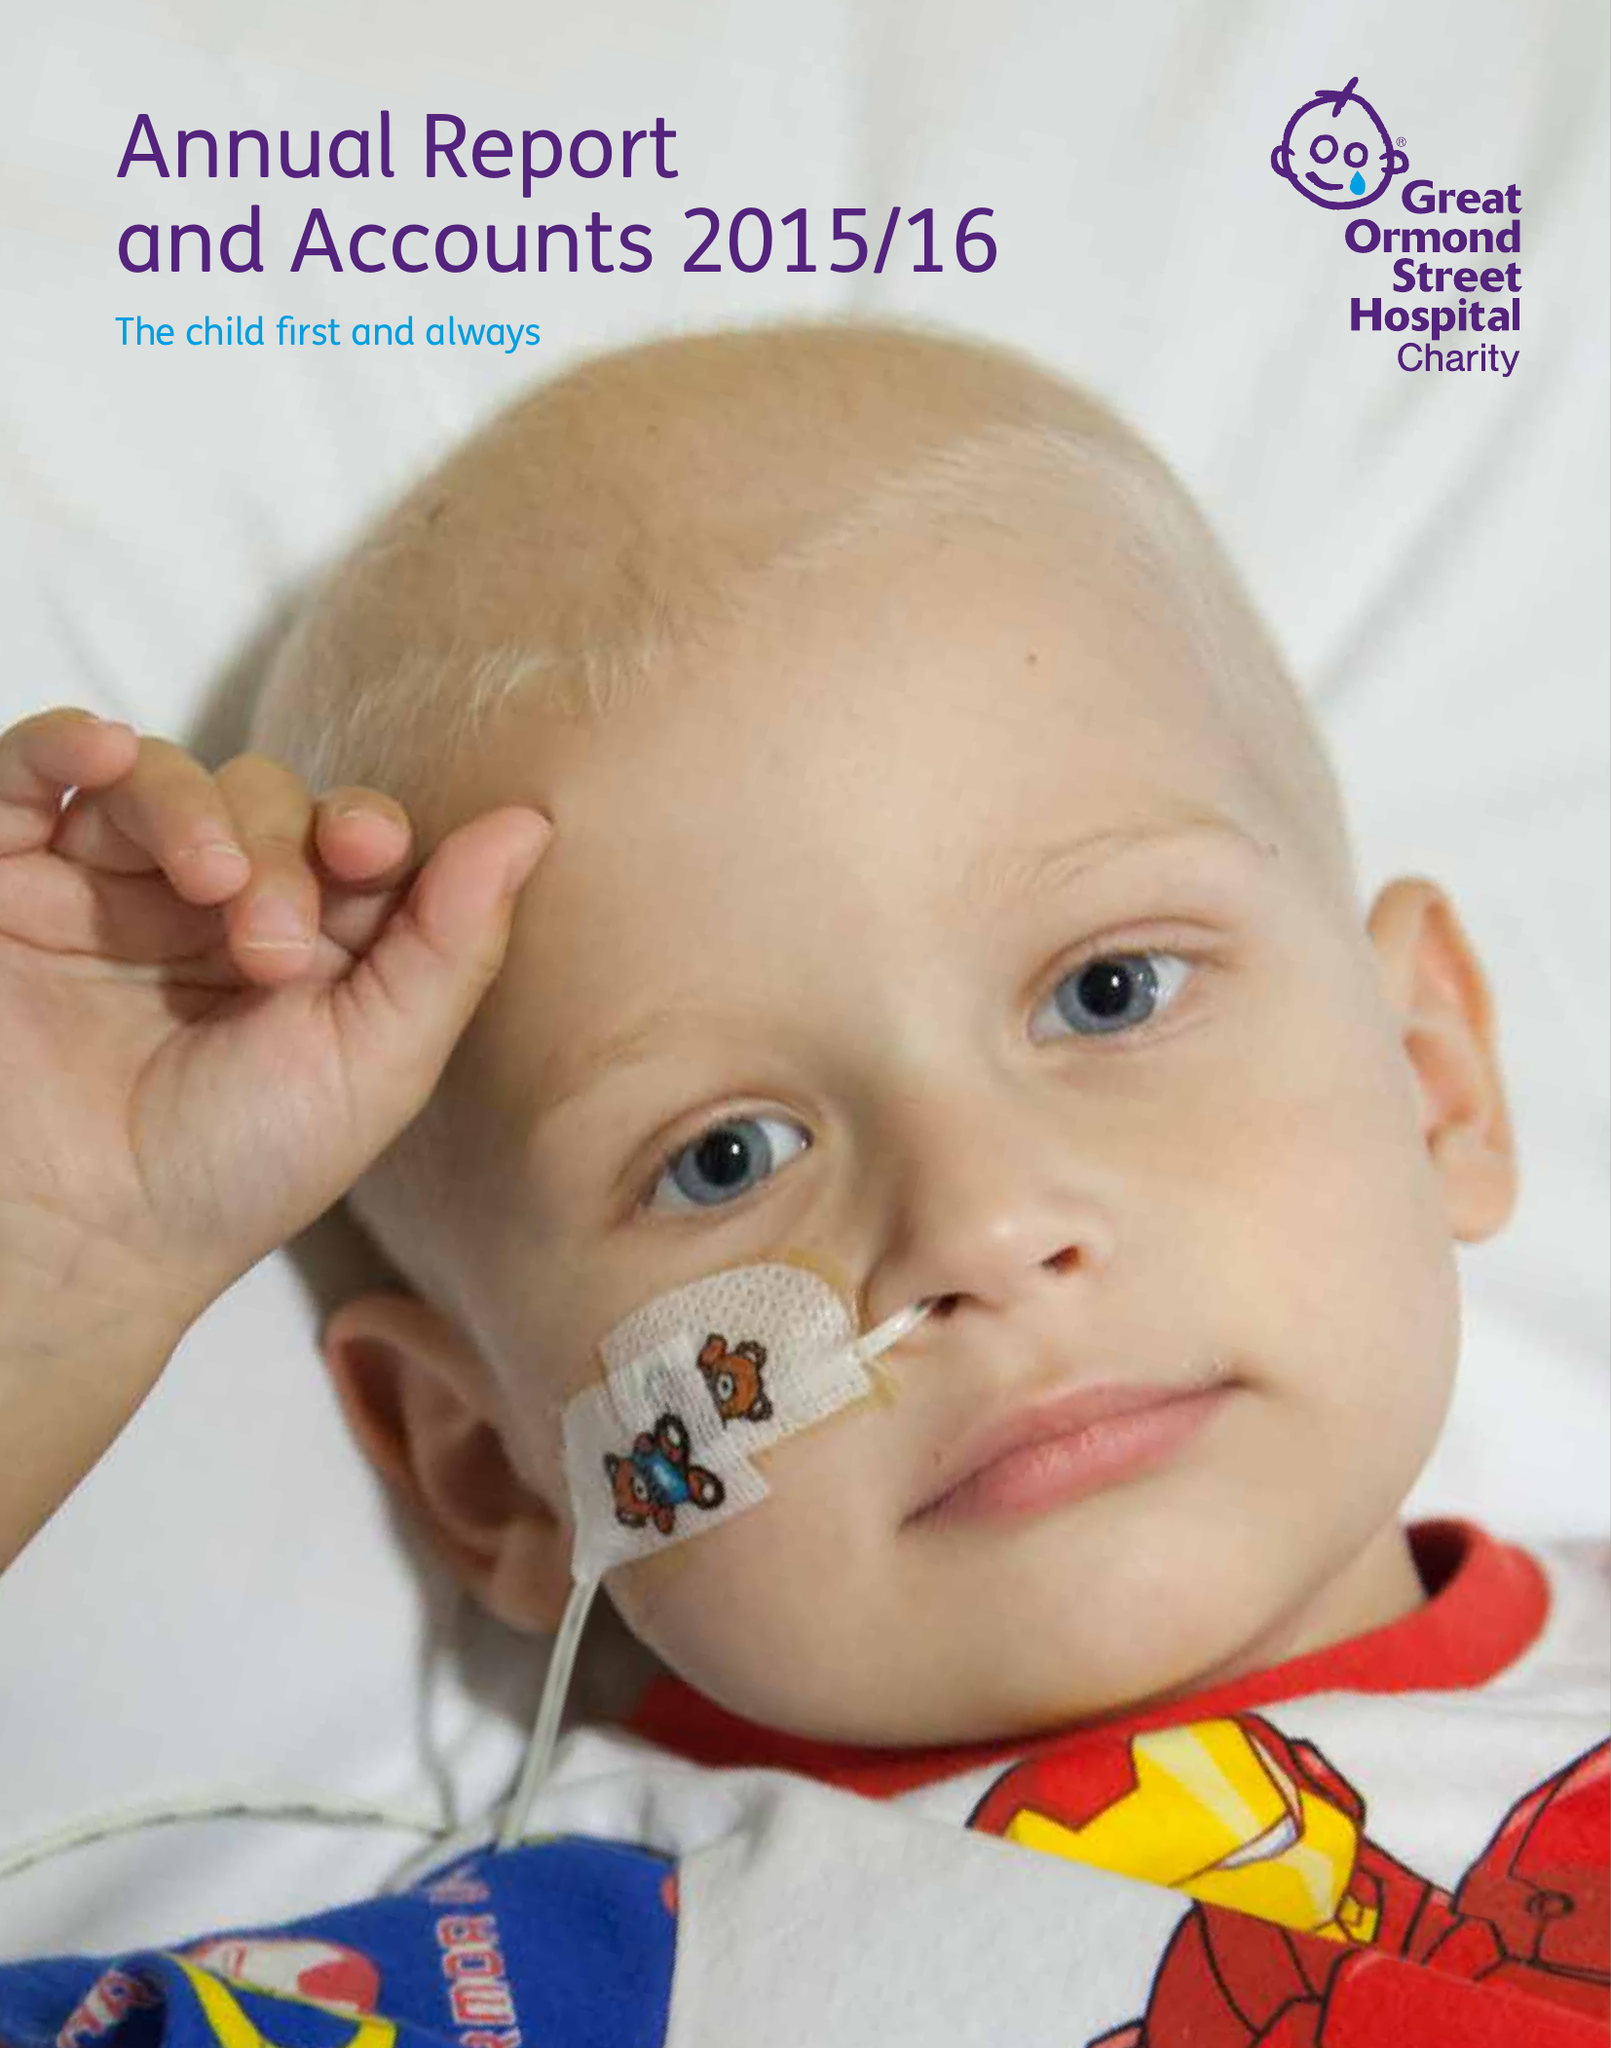What is the value for the charity_number?
Answer the question using a single word or phrase. 1160024 